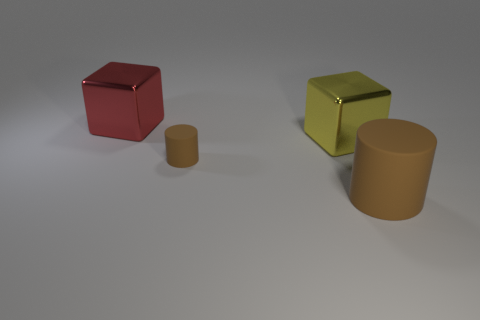Add 4 small brown rubber spheres. How many objects exist? 8 Subtract 0 red spheres. How many objects are left? 4 Subtract all brown matte things. Subtract all big brown things. How many objects are left? 1 Add 3 yellow objects. How many yellow objects are left? 4 Add 2 small matte cylinders. How many small matte cylinders exist? 3 